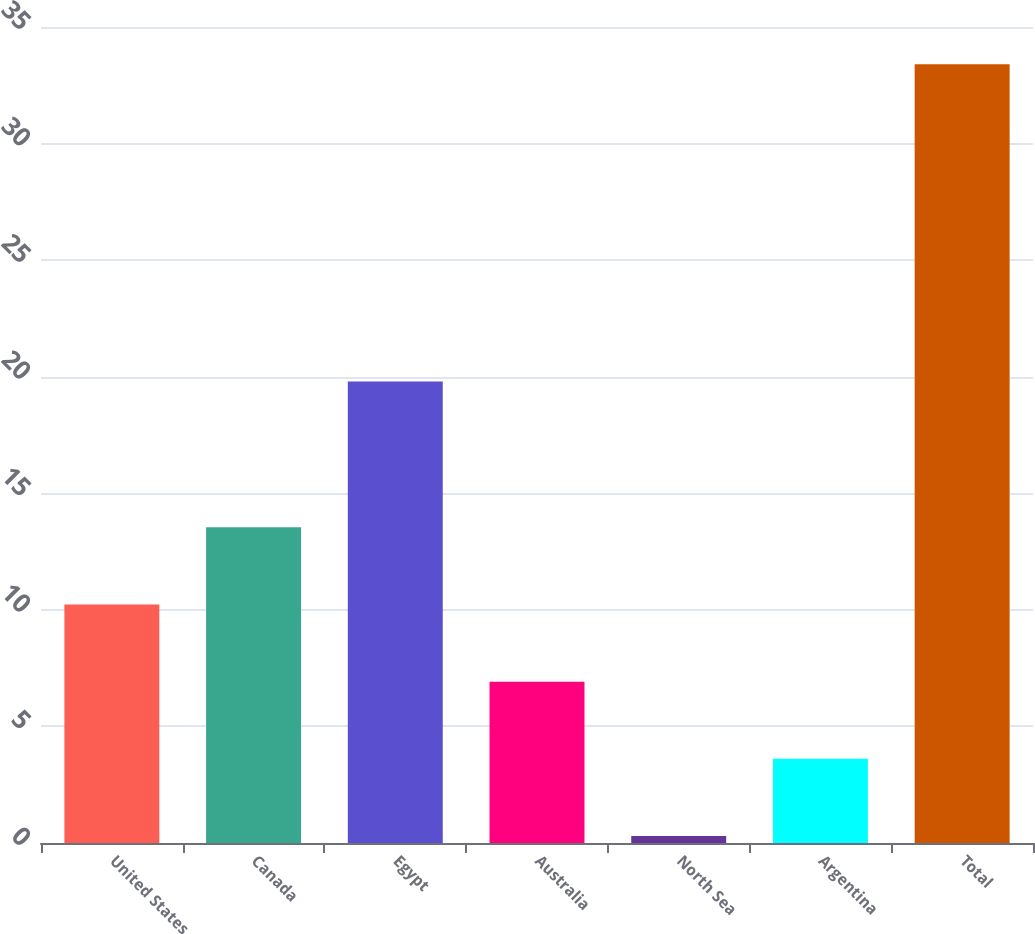Convert chart to OTSL. <chart><loc_0><loc_0><loc_500><loc_500><bar_chart><fcel>United States<fcel>Canada<fcel>Egypt<fcel>Australia<fcel>North Sea<fcel>Argentina<fcel>Total<nl><fcel>10.23<fcel>13.54<fcel>19.8<fcel>6.92<fcel>0.3<fcel>3.61<fcel>33.4<nl></chart> 